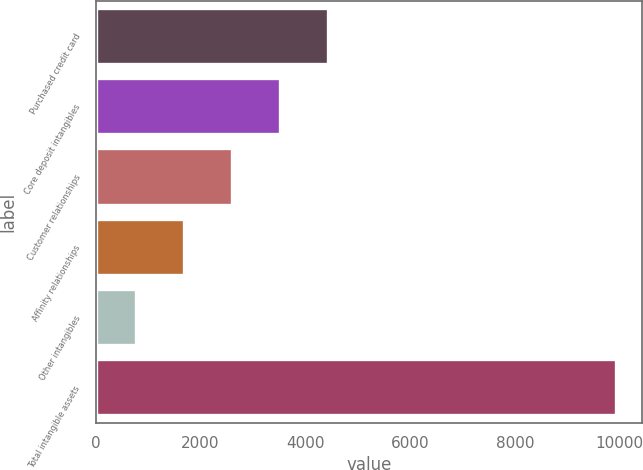Convert chart. <chart><loc_0><loc_0><loc_500><loc_500><bar_chart><fcel>Purchased credit card<fcel>Core deposit intangibles<fcel>Customer relationships<fcel>Affinity relationships<fcel>Other intangibles<fcel>Total intangible assets<nl><fcel>4432<fcel>3516<fcel>2600<fcel>1684<fcel>768<fcel>9928<nl></chart> 